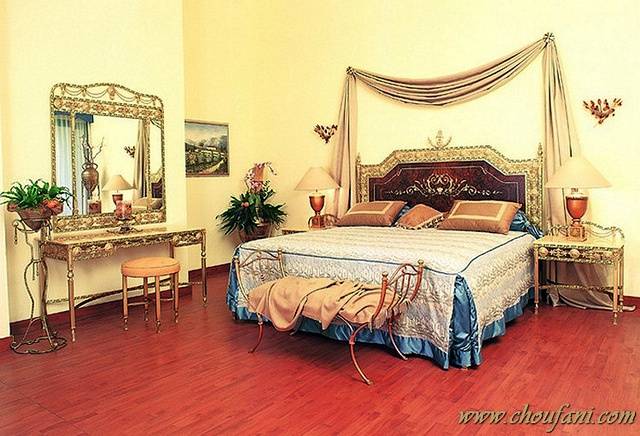Describe the objects in this image and their specific colors. I can see bed in khaki, tan, beige, and black tones, potted plant in khaki, black, olive, and darkgreen tones, potted plant in khaki, black, olive, and maroon tones, chair in khaki, orange, maroon, brown, and salmon tones, and vase in khaki, gray, and maroon tones in this image. 